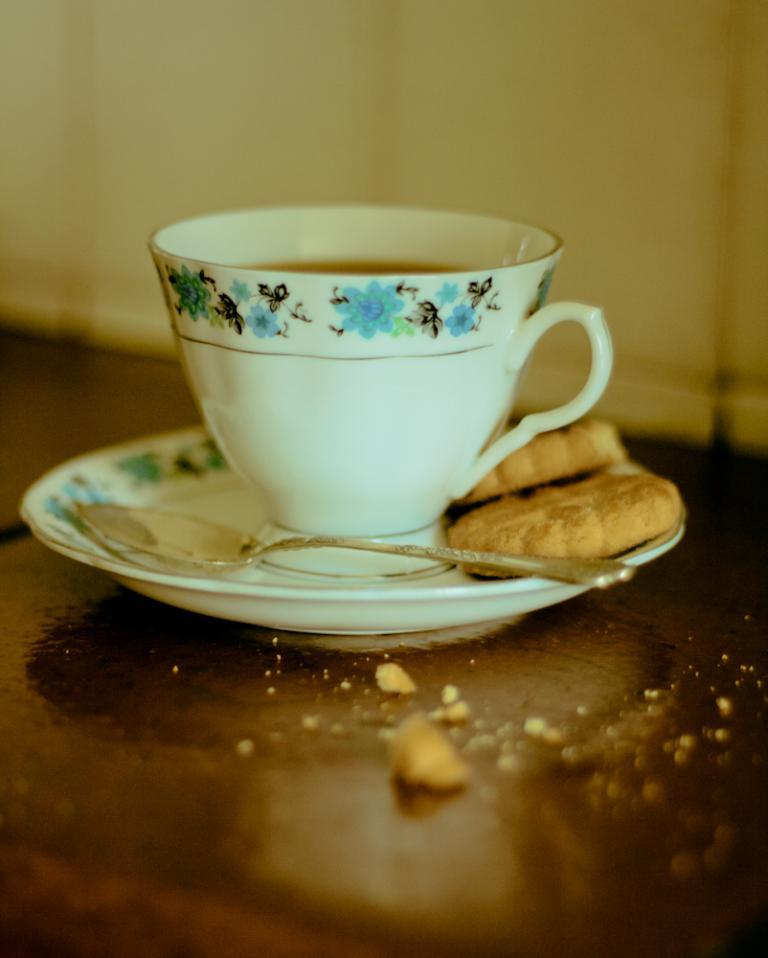What utensil is visible in the image? There is a spoon in the image. What type of container is present in the image? There is a cup in the image. What type of food is in the saucer in the image? There are biscuits in the saucer in the image. Can you describe the background of the image? The background of the image is blurry. Where is the bucket located in the image? There is no bucket present in the image. What type of bear can be seen interacting with the biscuits in the image? There is no bear present in the image; only the spoon, cup, biscuits, and saucer are visible. 